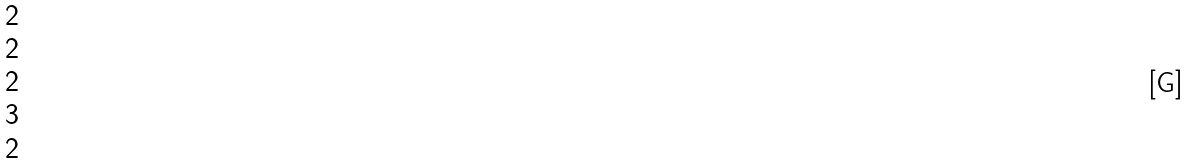<formula> <loc_0><loc_0><loc_500><loc_500>\begin{matrix} 2 \\ 2 \\ 2 \\ 3 \\ 2 \end{matrix}</formula> 